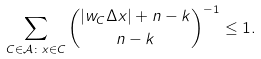<formula> <loc_0><loc_0><loc_500><loc_500>\sum _ { C \in \mathcal { A } \colon x \in C } { | w _ { C } \Delta x | + n - k \choose n - k } ^ { - 1 } \leq 1 .</formula> 